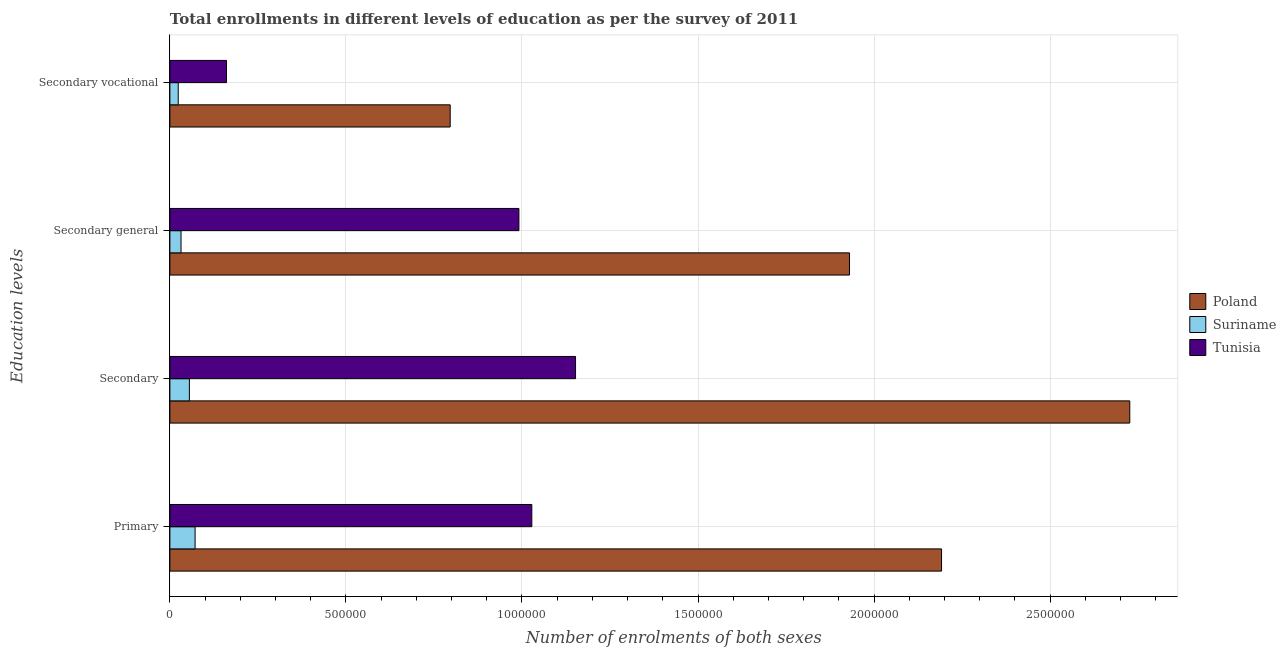How many groups of bars are there?
Offer a very short reply. 4. Are the number of bars per tick equal to the number of legend labels?
Your answer should be compact. Yes. Are the number of bars on each tick of the Y-axis equal?
Keep it short and to the point. Yes. What is the label of the 1st group of bars from the top?
Keep it short and to the point. Secondary vocational. What is the number of enrolments in secondary general education in Poland?
Offer a terse response. 1.93e+06. Across all countries, what is the maximum number of enrolments in primary education?
Offer a terse response. 2.19e+06. Across all countries, what is the minimum number of enrolments in secondary vocational education?
Your response must be concise. 2.38e+04. In which country was the number of enrolments in secondary general education maximum?
Ensure brevity in your answer.  Poland. In which country was the number of enrolments in primary education minimum?
Ensure brevity in your answer.  Suriname. What is the total number of enrolments in secondary vocational education in the graph?
Offer a very short reply. 9.81e+05. What is the difference between the number of enrolments in primary education in Tunisia and that in Poland?
Your answer should be very brief. -1.16e+06. What is the difference between the number of enrolments in secondary general education in Suriname and the number of enrolments in primary education in Poland?
Your answer should be compact. -2.16e+06. What is the average number of enrolments in secondary education per country?
Your response must be concise. 1.31e+06. What is the difference between the number of enrolments in secondary education and number of enrolments in primary education in Poland?
Give a very brief answer. 5.35e+05. In how many countries, is the number of enrolments in primary education greater than 800000 ?
Your answer should be compact. 2. What is the ratio of the number of enrolments in secondary general education in Tunisia to that in Poland?
Give a very brief answer. 0.51. What is the difference between the highest and the second highest number of enrolments in secondary general education?
Give a very brief answer. 9.39e+05. What is the difference between the highest and the lowest number of enrolments in secondary general education?
Your response must be concise. 1.90e+06. In how many countries, is the number of enrolments in secondary vocational education greater than the average number of enrolments in secondary vocational education taken over all countries?
Provide a short and direct response. 1. What does the 3rd bar from the top in Secondary represents?
Your response must be concise. Poland. Are all the bars in the graph horizontal?
Offer a terse response. Yes. Does the graph contain any zero values?
Your response must be concise. No. What is the title of the graph?
Provide a succinct answer. Total enrollments in different levels of education as per the survey of 2011. What is the label or title of the X-axis?
Your answer should be compact. Number of enrolments of both sexes. What is the label or title of the Y-axis?
Make the answer very short. Education levels. What is the Number of enrolments of both sexes in Poland in Primary?
Your answer should be compact. 2.19e+06. What is the Number of enrolments of both sexes of Suriname in Primary?
Provide a succinct answer. 7.16e+04. What is the Number of enrolments of both sexes in Tunisia in Primary?
Make the answer very short. 1.03e+06. What is the Number of enrolments of both sexes in Poland in Secondary?
Provide a succinct answer. 2.73e+06. What is the Number of enrolments of both sexes in Suriname in Secondary?
Your answer should be very brief. 5.54e+04. What is the Number of enrolments of both sexes in Tunisia in Secondary?
Keep it short and to the point. 1.15e+06. What is the Number of enrolments of both sexes of Poland in Secondary general?
Make the answer very short. 1.93e+06. What is the Number of enrolments of both sexes of Suriname in Secondary general?
Your response must be concise. 3.17e+04. What is the Number of enrolments of both sexes in Tunisia in Secondary general?
Keep it short and to the point. 9.91e+05. What is the Number of enrolments of both sexes of Poland in Secondary vocational?
Offer a very short reply. 7.96e+05. What is the Number of enrolments of both sexes of Suriname in Secondary vocational?
Offer a terse response. 2.38e+04. What is the Number of enrolments of both sexes in Tunisia in Secondary vocational?
Your response must be concise. 1.61e+05. Across all Education levels, what is the maximum Number of enrolments of both sexes of Poland?
Your response must be concise. 2.73e+06. Across all Education levels, what is the maximum Number of enrolments of both sexes in Suriname?
Provide a succinct answer. 7.16e+04. Across all Education levels, what is the maximum Number of enrolments of both sexes in Tunisia?
Ensure brevity in your answer.  1.15e+06. Across all Education levels, what is the minimum Number of enrolments of both sexes in Poland?
Provide a succinct answer. 7.96e+05. Across all Education levels, what is the minimum Number of enrolments of both sexes in Suriname?
Ensure brevity in your answer.  2.38e+04. Across all Education levels, what is the minimum Number of enrolments of both sexes of Tunisia?
Offer a very short reply. 1.61e+05. What is the total Number of enrolments of both sexes in Poland in the graph?
Your answer should be very brief. 7.64e+06. What is the total Number of enrolments of both sexes of Suriname in the graph?
Offer a very short reply. 1.82e+05. What is the total Number of enrolments of both sexes in Tunisia in the graph?
Give a very brief answer. 3.33e+06. What is the difference between the Number of enrolments of both sexes in Poland in Primary and that in Secondary?
Your response must be concise. -5.35e+05. What is the difference between the Number of enrolments of both sexes in Suriname in Primary and that in Secondary?
Make the answer very short. 1.62e+04. What is the difference between the Number of enrolments of both sexes of Tunisia in Primary and that in Secondary?
Keep it short and to the point. -1.24e+05. What is the difference between the Number of enrolments of both sexes of Poland in Primary and that in Secondary general?
Your response must be concise. 2.62e+05. What is the difference between the Number of enrolments of both sexes of Suriname in Primary and that in Secondary general?
Ensure brevity in your answer.  3.99e+04. What is the difference between the Number of enrolments of both sexes in Tunisia in Primary and that in Secondary general?
Your answer should be very brief. 3.67e+04. What is the difference between the Number of enrolments of both sexes of Poland in Primary and that in Secondary vocational?
Provide a succinct answer. 1.40e+06. What is the difference between the Number of enrolments of both sexes of Suriname in Primary and that in Secondary vocational?
Ensure brevity in your answer.  4.78e+04. What is the difference between the Number of enrolments of both sexes in Tunisia in Primary and that in Secondary vocational?
Provide a short and direct response. 8.67e+05. What is the difference between the Number of enrolments of both sexes of Poland in Secondary and that in Secondary general?
Your answer should be compact. 7.96e+05. What is the difference between the Number of enrolments of both sexes of Suriname in Secondary and that in Secondary general?
Your response must be concise. 2.38e+04. What is the difference between the Number of enrolments of both sexes of Tunisia in Secondary and that in Secondary general?
Ensure brevity in your answer.  1.61e+05. What is the difference between the Number of enrolments of both sexes of Poland in Secondary and that in Secondary vocational?
Provide a succinct answer. 1.93e+06. What is the difference between the Number of enrolments of both sexes of Suriname in Secondary and that in Secondary vocational?
Ensure brevity in your answer.  3.17e+04. What is the difference between the Number of enrolments of both sexes in Tunisia in Secondary and that in Secondary vocational?
Provide a short and direct response. 9.91e+05. What is the difference between the Number of enrolments of both sexes of Poland in Secondary general and that in Secondary vocational?
Your response must be concise. 1.13e+06. What is the difference between the Number of enrolments of both sexes of Suriname in Secondary general and that in Secondary vocational?
Your response must be concise. 7917. What is the difference between the Number of enrolments of both sexes of Tunisia in Secondary general and that in Secondary vocational?
Keep it short and to the point. 8.30e+05. What is the difference between the Number of enrolments of both sexes of Poland in Primary and the Number of enrolments of both sexes of Suriname in Secondary?
Give a very brief answer. 2.14e+06. What is the difference between the Number of enrolments of both sexes of Poland in Primary and the Number of enrolments of both sexes of Tunisia in Secondary?
Ensure brevity in your answer.  1.04e+06. What is the difference between the Number of enrolments of both sexes of Suriname in Primary and the Number of enrolments of both sexes of Tunisia in Secondary?
Keep it short and to the point. -1.08e+06. What is the difference between the Number of enrolments of both sexes in Poland in Primary and the Number of enrolments of both sexes in Suriname in Secondary general?
Your answer should be very brief. 2.16e+06. What is the difference between the Number of enrolments of both sexes of Poland in Primary and the Number of enrolments of both sexes of Tunisia in Secondary general?
Give a very brief answer. 1.20e+06. What is the difference between the Number of enrolments of both sexes of Suriname in Primary and the Number of enrolments of both sexes of Tunisia in Secondary general?
Offer a very short reply. -9.20e+05. What is the difference between the Number of enrolments of both sexes in Poland in Primary and the Number of enrolments of both sexes in Suriname in Secondary vocational?
Provide a succinct answer. 2.17e+06. What is the difference between the Number of enrolments of both sexes of Poland in Primary and the Number of enrolments of both sexes of Tunisia in Secondary vocational?
Your answer should be very brief. 2.03e+06. What is the difference between the Number of enrolments of both sexes in Suriname in Primary and the Number of enrolments of both sexes in Tunisia in Secondary vocational?
Offer a very short reply. -8.92e+04. What is the difference between the Number of enrolments of both sexes in Poland in Secondary and the Number of enrolments of both sexes in Suriname in Secondary general?
Give a very brief answer. 2.69e+06. What is the difference between the Number of enrolments of both sexes of Poland in Secondary and the Number of enrolments of both sexes of Tunisia in Secondary general?
Keep it short and to the point. 1.73e+06. What is the difference between the Number of enrolments of both sexes in Suriname in Secondary and the Number of enrolments of both sexes in Tunisia in Secondary general?
Provide a succinct answer. -9.36e+05. What is the difference between the Number of enrolments of both sexes of Poland in Secondary and the Number of enrolments of both sexes of Suriname in Secondary vocational?
Keep it short and to the point. 2.70e+06. What is the difference between the Number of enrolments of both sexes of Poland in Secondary and the Number of enrolments of both sexes of Tunisia in Secondary vocational?
Ensure brevity in your answer.  2.57e+06. What is the difference between the Number of enrolments of both sexes in Suriname in Secondary and the Number of enrolments of both sexes in Tunisia in Secondary vocational?
Give a very brief answer. -1.05e+05. What is the difference between the Number of enrolments of both sexes in Poland in Secondary general and the Number of enrolments of both sexes in Suriname in Secondary vocational?
Your response must be concise. 1.91e+06. What is the difference between the Number of enrolments of both sexes in Poland in Secondary general and the Number of enrolments of both sexes in Tunisia in Secondary vocational?
Your response must be concise. 1.77e+06. What is the difference between the Number of enrolments of both sexes of Suriname in Secondary general and the Number of enrolments of both sexes of Tunisia in Secondary vocational?
Offer a very short reply. -1.29e+05. What is the average Number of enrolments of both sexes of Poland per Education levels?
Offer a very short reply. 1.91e+06. What is the average Number of enrolments of both sexes in Suriname per Education levels?
Provide a short and direct response. 4.56e+04. What is the average Number of enrolments of both sexes in Tunisia per Education levels?
Your response must be concise. 8.33e+05. What is the difference between the Number of enrolments of both sexes of Poland and Number of enrolments of both sexes of Suriname in Primary?
Provide a short and direct response. 2.12e+06. What is the difference between the Number of enrolments of both sexes of Poland and Number of enrolments of both sexes of Tunisia in Primary?
Provide a short and direct response. 1.16e+06. What is the difference between the Number of enrolments of both sexes of Suriname and Number of enrolments of both sexes of Tunisia in Primary?
Ensure brevity in your answer.  -9.56e+05. What is the difference between the Number of enrolments of both sexes of Poland and Number of enrolments of both sexes of Suriname in Secondary?
Provide a short and direct response. 2.67e+06. What is the difference between the Number of enrolments of both sexes in Poland and Number of enrolments of both sexes in Tunisia in Secondary?
Ensure brevity in your answer.  1.57e+06. What is the difference between the Number of enrolments of both sexes in Suriname and Number of enrolments of both sexes in Tunisia in Secondary?
Offer a terse response. -1.10e+06. What is the difference between the Number of enrolments of both sexes of Poland and Number of enrolments of both sexes of Suriname in Secondary general?
Your answer should be compact. 1.90e+06. What is the difference between the Number of enrolments of both sexes of Poland and Number of enrolments of both sexes of Tunisia in Secondary general?
Offer a terse response. 9.39e+05. What is the difference between the Number of enrolments of both sexes in Suriname and Number of enrolments of both sexes in Tunisia in Secondary general?
Ensure brevity in your answer.  -9.60e+05. What is the difference between the Number of enrolments of both sexes in Poland and Number of enrolments of both sexes in Suriname in Secondary vocational?
Your answer should be very brief. 7.72e+05. What is the difference between the Number of enrolments of both sexes in Poland and Number of enrolments of both sexes in Tunisia in Secondary vocational?
Keep it short and to the point. 6.35e+05. What is the difference between the Number of enrolments of both sexes of Suriname and Number of enrolments of both sexes of Tunisia in Secondary vocational?
Keep it short and to the point. -1.37e+05. What is the ratio of the Number of enrolments of both sexes of Poland in Primary to that in Secondary?
Your response must be concise. 0.8. What is the ratio of the Number of enrolments of both sexes in Suriname in Primary to that in Secondary?
Provide a short and direct response. 1.29. What is the ratio of the Number of enrolments of both sexes in Tunisia in Primary to that in Secondary?
Your answer should be very brief. 0.89. What is the ratio of the Number of enrolments of both sexes of Poland in Primary to that in Secondary general?
Make the answer very short. 1.14. What is the ratio of the Number of enrolments of both sexes in Suriname in Primary to that in Secondary general?
Your response must be concise. 2.26. What is the ratio of the Number of enrolments of both sexes of Tunisia in Primary to that in Secondary general?
Your answer should be compact. 1.04. What is the ratio of the Number of enrolments of both sexes in Poland in Primary to that in Secondary vocational?
Provide a short and direct response. 2.75. What is the ratio of the Number of enrolments of both sexes in Suriname in Primary to that in Secondary vocational?
Offer a very short reply. 3.01. What is the ratio of the Number of enrolments of both sexes in Tunisia in Primary to that in Secondary vocational?
Give a very brief answer. 6.39. What is the ratio of the Number of enrolments of both sexes of Poland in Secondary to that in Secondary general?
Keep it short and to the point. 1.41. What is the ratio of the Number of enrolments of both sexes of Suriname in Secondary to that in Secondary general?
Your response must be concise. 1.75. What is the ratio of the Number of enrolments of both sexes of Tunisia in Secondary to that in Secondary general?
Your answer should be compact. 1.16. What is the ratio of the Number of enrolments of both sexes of Poland in Secondary to that in Secondary vocational?
Offer a very short reply. 3.42. What is the ratio of the Number of enrolments of both sexes of Suriname in Secondary to that in Secondary vocational?
Offer a terse response. 2.33. What is the ratio of the Number of enrolments of both sexes of Tunisia in Secondary to that in Secondary vocational?
Ensure brevity in your answer.  7.16. What is the ratio of the Number of enrolments of both sexes in Poland in Secondary general to that in Secondary vocational?
Your answer should be compact. 2.42. What is the ratio of the Number of enrolments of both sexes of Suriname in Secondary general to that in Secondary vocational?
Ensure brevity in your answer.  1.33. What is the ratio of the Number of enrolments of both sexes in Tunisia in Secondary general to that in Secondary vocational?
Ensure brevity in your answer.  6.16. What is the difference between the highest and the second highest Number of enrolments of both sexes of Poland?
Keep it short and to the point. 5.35e+05. What is the difference between the highest and the second highest Number of enrolments of both sexes in Suriname?
Give a very brief answer. 1.62e+04. What is the difference between the highest and the second highest Number of enrolments of both sexes in Tunisia?
Offer a terse response. 1.24e+05. What is the difference between the highest and the lowest Number of enrolments of both sexes of Poland?
Provide a succinct answer. 1.93e+06. What is the difference between the highest and the lowest Number of enrolments of both sexes in Suriname?
Provide a succinct answer. 4.78e+04. What is the difference between the highest and the lowest Number of enrolments of both sexes in Tunisia?
Provide a short and direct response. 9.91e+05. 